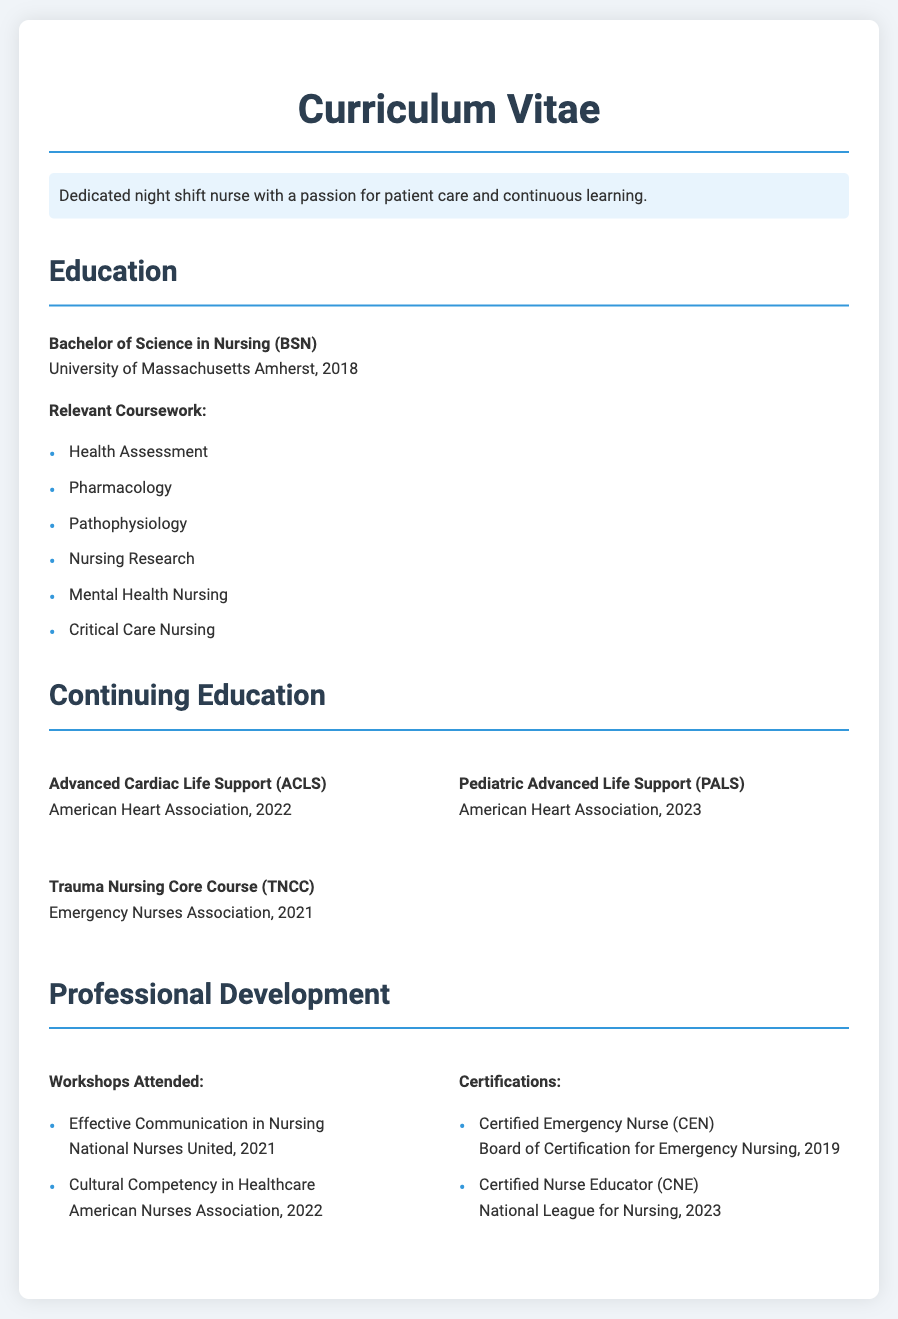What degree is listed in the education section? The education section lists the Bachelor of Science in Nursing (BSN) as the degree obtained.
Answer: Bachelor of Science in Nursing (BSN) When did the nurse graduate from college? The graduation date for the degree is included in the education section, which states the year of graduation as 2018.
Answer: 2018 Which course focuses on patient assessment? The relevant coursework includes a specific course that teaches skills related to evaluating patients' health status, which is Health Assessment.
Answer: Health Assessment What certification was obtained in 2022? The continuing education section includes a certification completed in 2022, which is Advanced Cardiac Life Support (ACLS).
Answer: Advanced Cardiac Life Support (ACLS) How many continuing education courses are listed? The continuing education section details three different courses related to advanced life support and trauma nursing.
Answer: 3 What organization provided the Pediatric Advanced Life Support (PALS) course? The document specifies that the Pediatric Advanced Life Support (PALS) course was offered by the American Heart Association.
Answer: American Heart Association Which certification was achieved most recently? The professional development section indicates the most recent certification is Certified Nurse Educator (CNE), achieved in 2023.
Answer: Certified Nurse Educator (CNE) What type of nursing course focuses on trauma care? The continuing education section lists a course specializing in trauma care which is the Trauma Nursing Core Course (TNCC).
Answer: Trauma Nursing Core Course (TNCC) How many workshops attended are mentioned? The professional development section describes two workshops attended by the nurse.
Answer: 2 